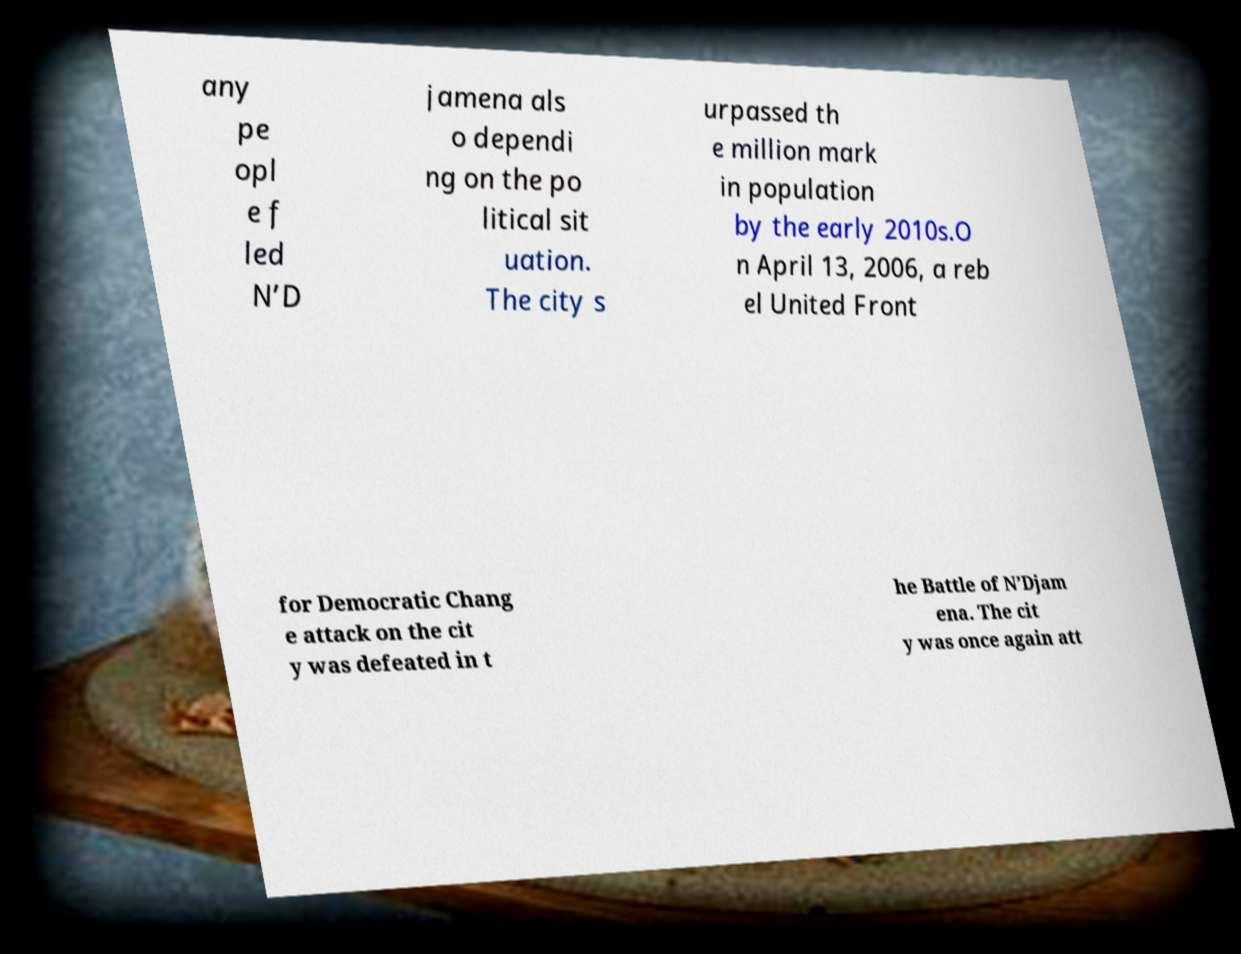Could you extract and type out the text from this image? any pe opl e f led N’D jamena als o dependi ng on the po litical sit uation. The city s urpassed th e million mark in population by the early 2010s.O n April 13, 2006, a reb el United Front for Democratic Chang e attack on the cit y was defeated in t he Battle of N’Djam ena. The cit y was once again att 